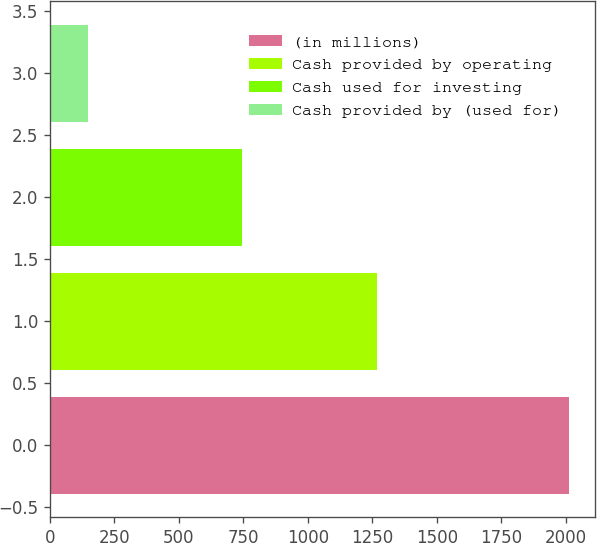Convert chart to OTSL. <chart><loc_0><loc_0><loc_500><loc_500><bar_chart><fcel>(in millions)<fcel>Cash provided by operating<fcel>Cash used for investing<fcel>Cash provided by (used for)<nl><fcel>2014<fcel>1269<fcel>745<fcel>150<nl></chart> 